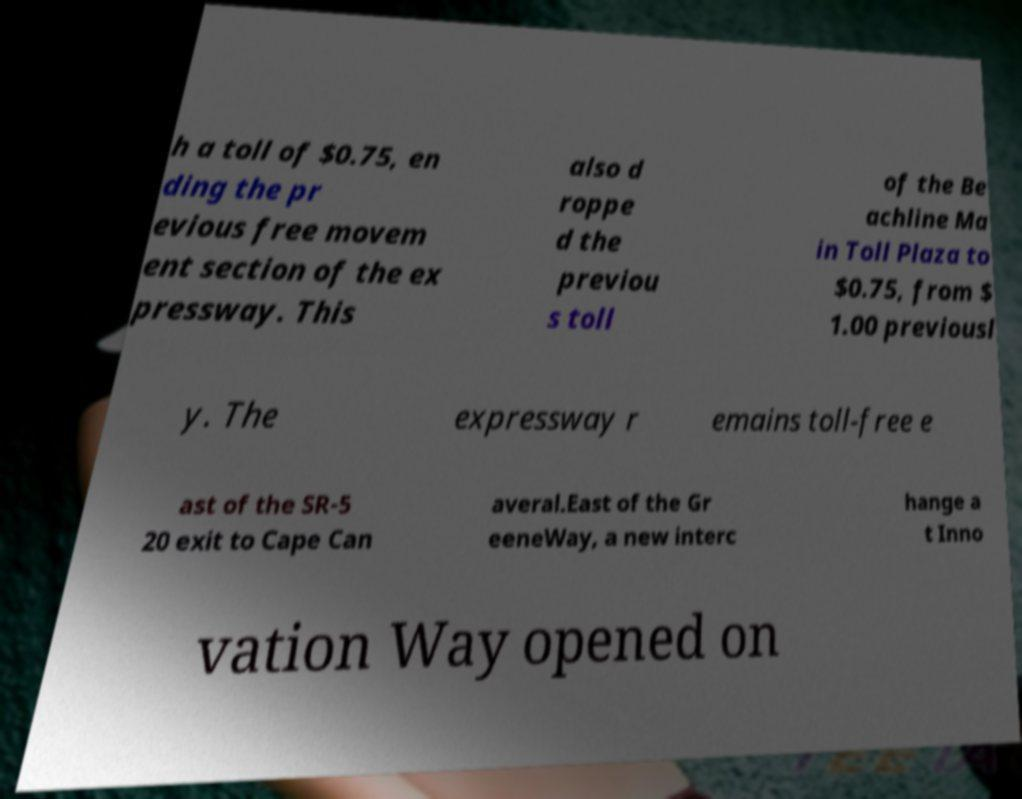There's text embedded in this image that I need extracted. Can you transcribe it verbatim? h a toll of $0.75, en ding the pr evious free movem ent section of the ex pressway. This also d roppe d the previou s toll of the Be achline Ma in Toll Plaza to $0.75, from $ 1.00 previousl y. The expressway r emains toll-free e ast of the SR-5 20 exit to Cape Can averal.East of the Gr eeneWay, a new interc hange a t Inno vation Way opened on 